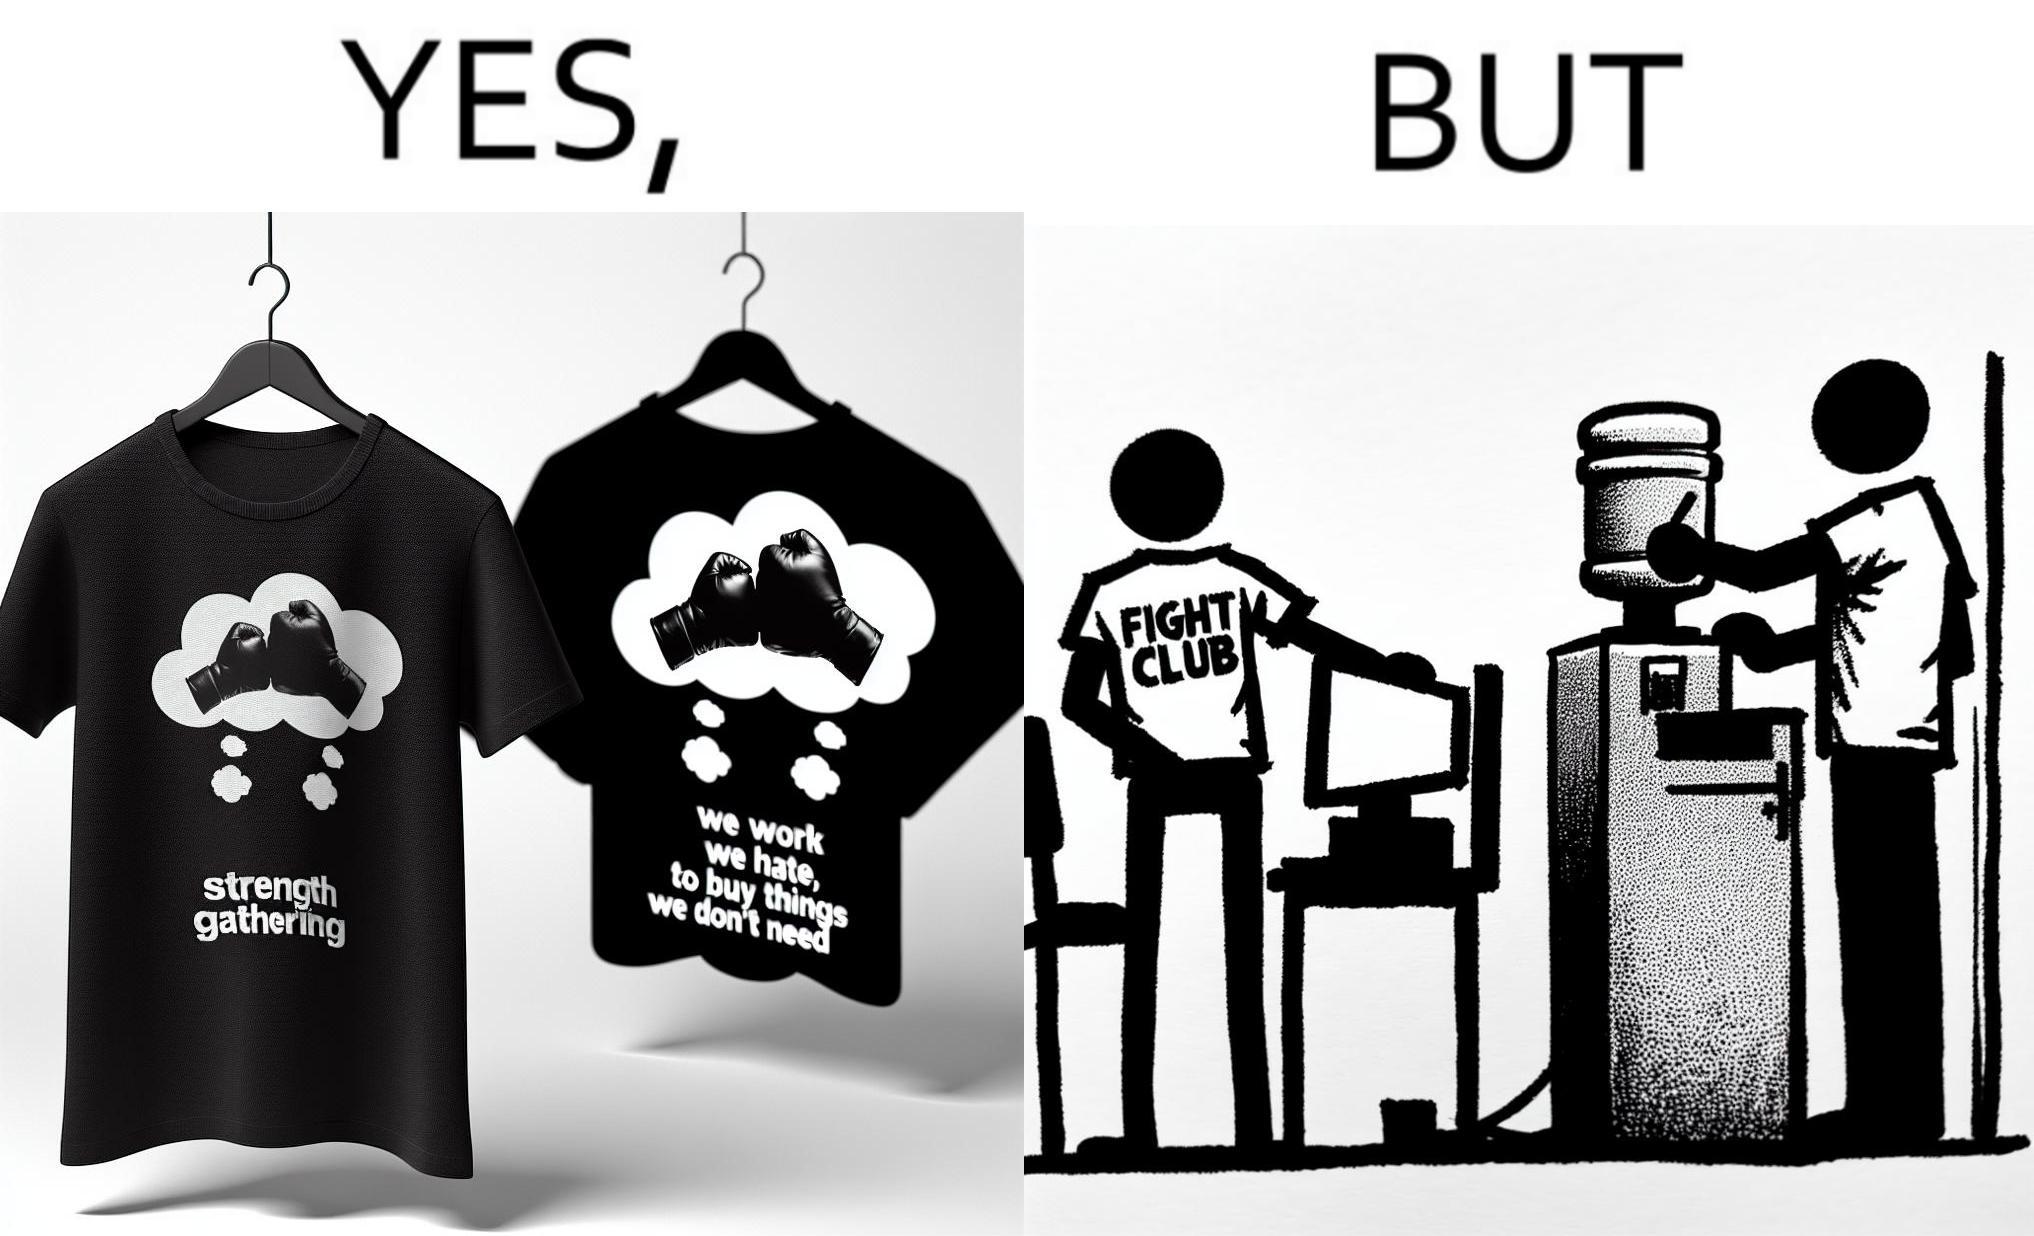What does this image depict? The image is ironical, as the t-shirt says "We work jobs we hate, to buy sh*t we don't need", which is a rebellious message against the construct of office jobs. However, the person wearing the t-shirt seems to be working in an office environment. Also, the t-shirt might have been bought using the money earned via the very same job. 